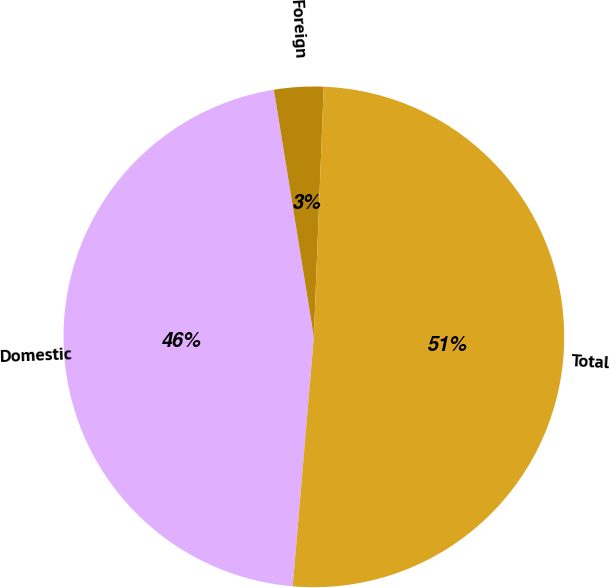Convert chart to OTSL. <chart><loc_0><loc_0><loc_500><loc_500><pie_chart><fcel>Domestic<fcel>Foreign<fcel>Total<nl><fcel>46.1%<fcel>3.18%<fcel>50.71%<nl></chart> 